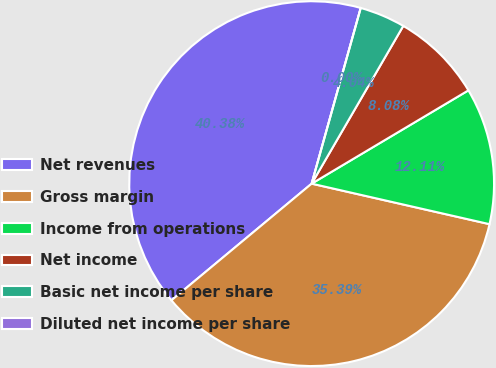<chart> <loc_0><loc_0><loc_500><loc_500><pie_chart><fcel>Net revenues<fcel>Gross margin<fcel>Income from operations<fcel>Net income<fcel>Basic net income per share<fcel>Diluted net income per share<nl><fcel>40.38%<fcel>35.39%<fcel>12.11%<fcel>8.08%<fcel>4.04%<fcel>0.0%<nl></chart> 